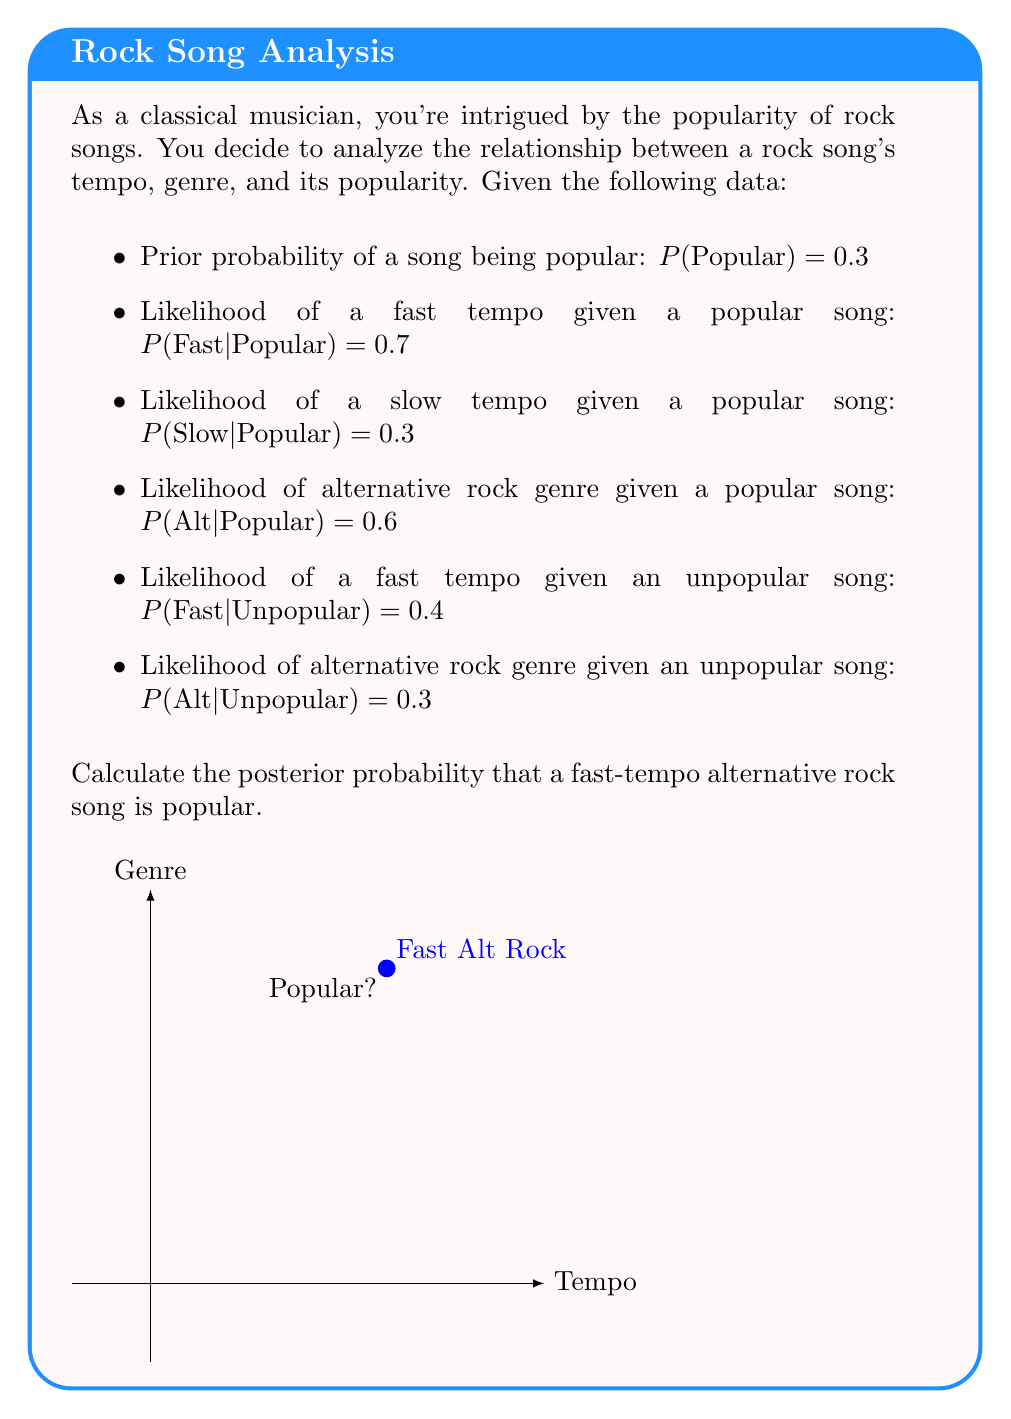Can you answer this question? Let's approach this step-by-step using Bayes' theorem:

1) We want to find $P(Popular|Fast,Alt)$

2) Bayes' theorem states:
   $$P(Popular|Fast,Alt) = \frac{P(Fast,Alt|Popular) \cdot P(Popular)}{P(Fast,Alt)}$$

3) We can calculate $P(Fast,Alt|Popular)$ assuming independence:
   $P(Fast,Alt|Popular) = P(Fast|Popular) \cdot P(Alt|Popular) = 0.7 \cdot 0.6 = 0.42$

4) We know $P(Popular) = 0.3$

5) We need to calculate $P(Fast,Alt)$ using the law of total probability:
   $P(Fast,Alt) = P(Fast,Alt|Popular) \cdot P(Popular) + P(Fast,Alt|Unpopular) \cdot P(Unpopular)$

6) We can calculate $P(Fast,Alt|Unpopular)$ assuming independence:
   $P(Fast,Alt|Unpopular) = P(Fast|Unpopular) \cdot P(Alt|Unpopular) = 0.4 \cdot 0.3 = 0.12$

7) $P(Unpopular) = 1 - P(Popular) = 0.7$

8) Now we can calculate $P(Fast,Alt)$:
   $P(Fast,Alt) = 0.42 \cdot 0.3 + 0.12 \cdot 0.7 = 0.126 + 0.084 = 0.21$

9) Finally, we can apply Bayes' theorem:
   $$P(Popular|Fast,Alt) = \frac{0.42 \cdot 0.3}{0.21} = \frac{0.126}{0.21} = 0.6$$

Therefore, the posterior probability that a fast-tempo alternative rock song is popular is 0.6 or 60%.
Answer: 0.6 